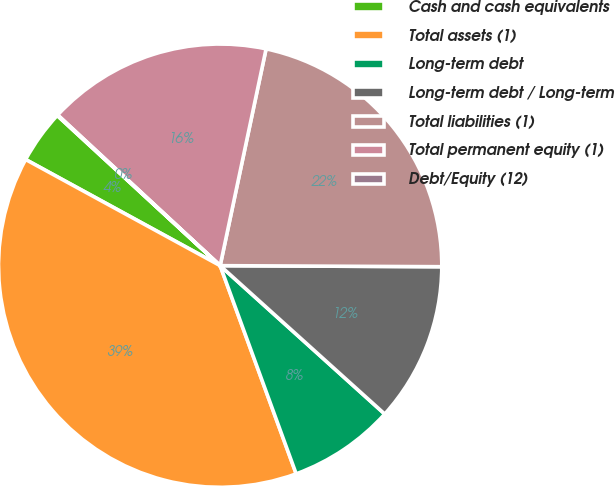Convert chart. <chart><loc_0><loc_0><loc_500><loc_500><pie_chart><fcel>Cash and cash equivalents<fcel>Total assets (1)<fcel>Long-term debt<fcel>Long-term debt / Long-term<fcel>Total liabilities (1)<fcel>Total permanent equity (1)<fcel>Debt/Equity (12)<nl><fcel>3.9%<fcel>38.52%<fcel>7.75%<fcel>11.6%<fcel>21.75%<fcel>16.42%<fcel>0.05%<nl></chart> 